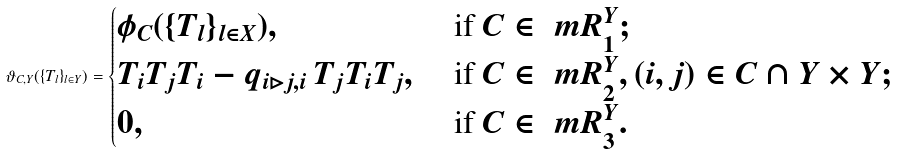<formula> <loc_0><loc_0><loc_500><loc_500>\vartheta _ { C , Y } ( \{ T _ { l } \} _ { l \in Y } ) = \begin{cases} \phi _ { C } ( \{ T _ { l } \} _ { l \in X } ) , & \text { if } C \in \ m R ^ { Y } _ { 1 } ; \\ T _ { i } T _ { j } T _ { i } - q _ { i \rhd j , i } \, T _ { j } T _ { i } T _ { j } , & \text { if } C \in \ m R ^ { Y } _ { 2 } , ( i , j ) \in C \cap Y \times Y ; \\ 0 , & \text { if } C \in \ m R ^ { Y } _ { 3 } . \end{cases}</formula> 